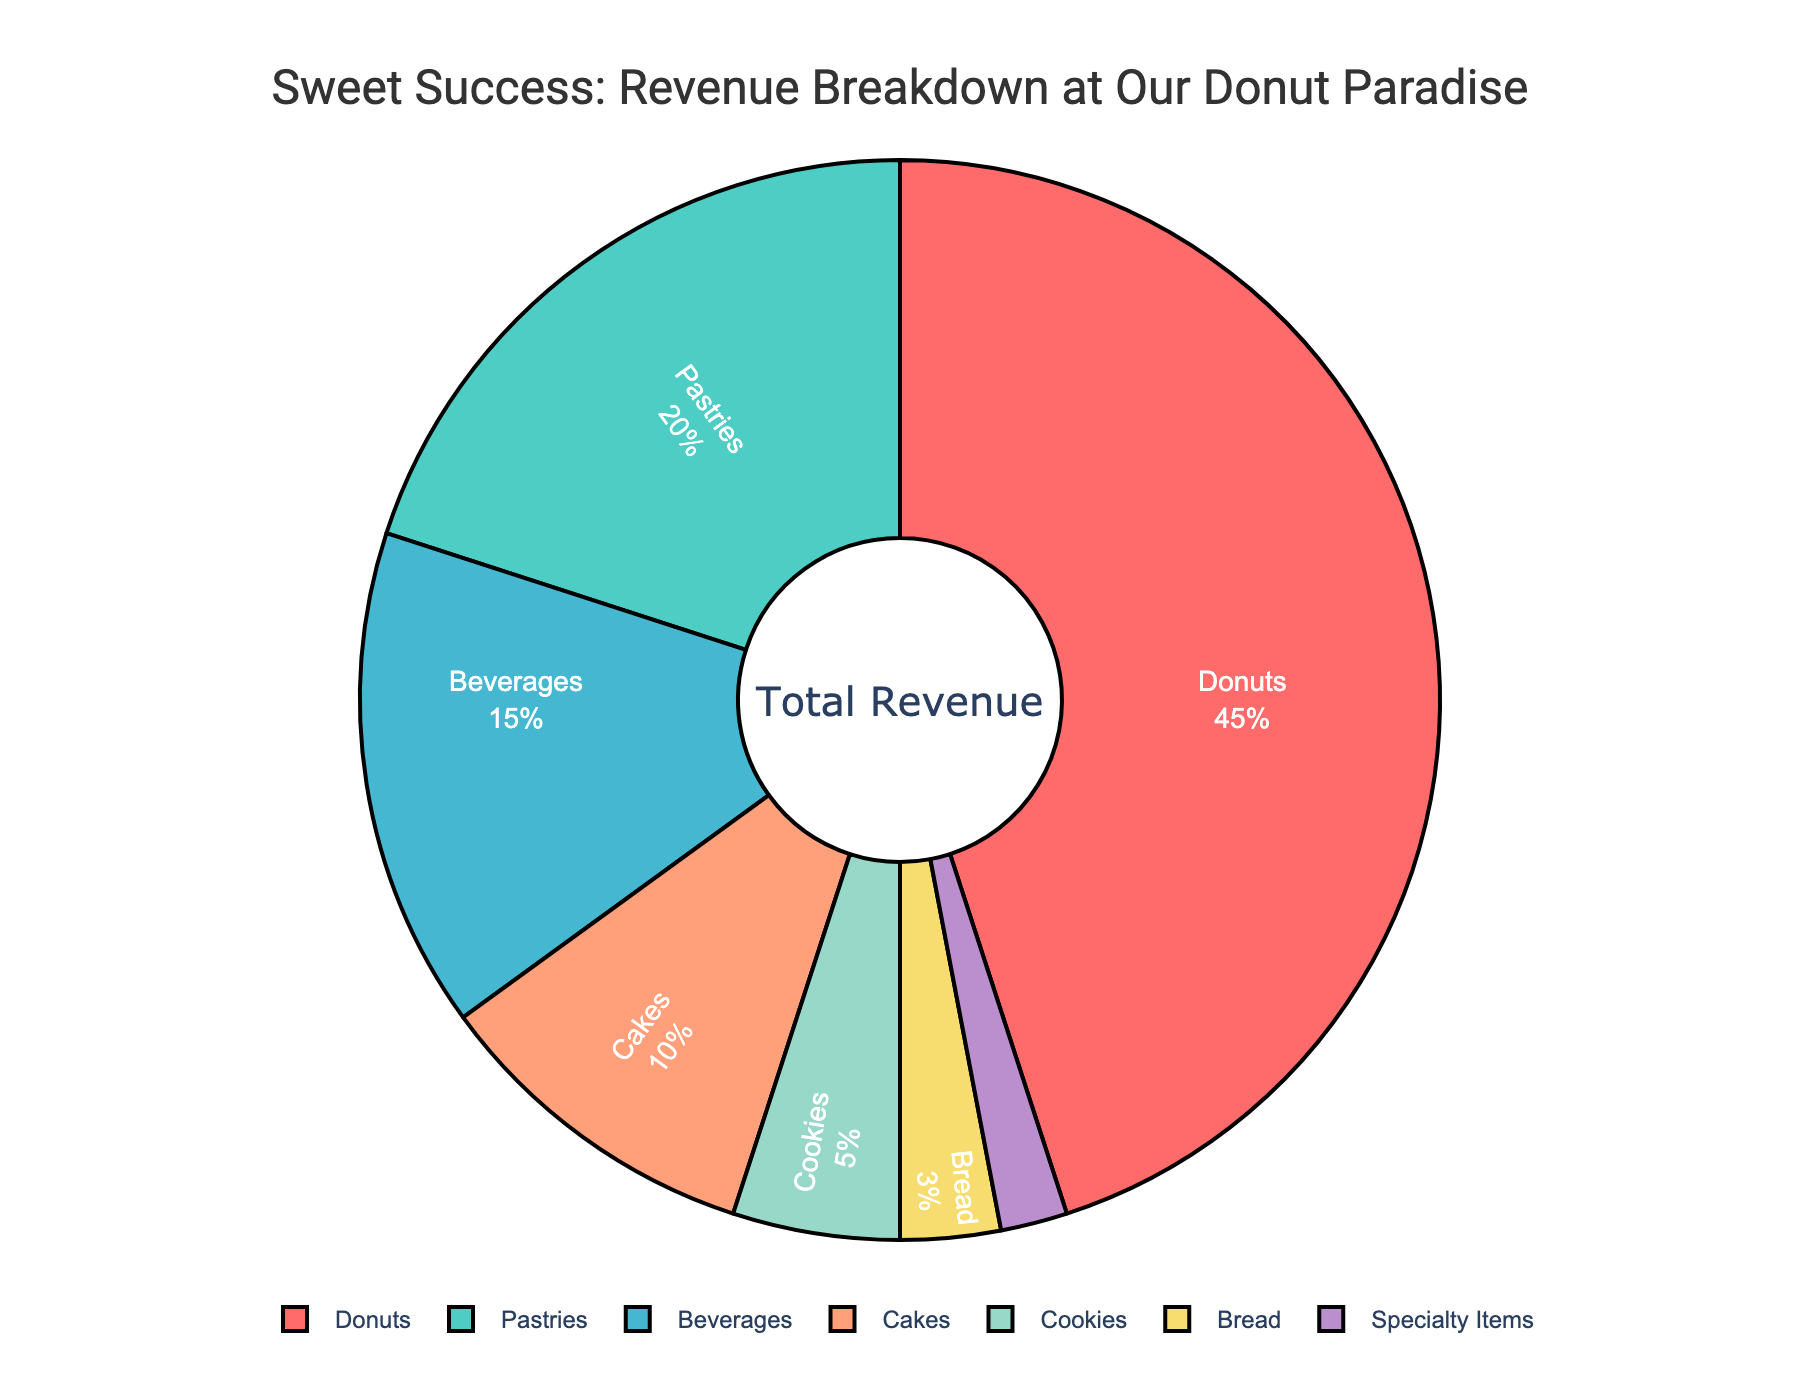Which product category generates the highest percentage of revenue? The largest segment of the pie chart belongs to the 'Donuts' category, indicating it contributes the highest percentage to the revenue.
Answer: Donuts How much more revenue percentage do donuts generate compared to beverages? The revenue percentage for donuts is 45%, and for beverages, it is 15%. The difference can be calculated as 45% - 15% = 30%.
Answer: 30% Which two product categories combined generate the same percentage of revenue as donuts? Pastries contribute 20% and cakes contribute 10%, combining these we get 20% + 10% = 30%. This is not equal to donuts' 45%. Combining pastries (20%) and beverages (15%) yields 20% + 15% = 35%, still not equal. The closest combination is pastries (20%), beverages (15%), and cookies (5%), 20% + 15% + 5% = 40%. Therefore, no combination of two categories matches the donut's revenue percentage.
Answer: None What percentage of revenue comes from products other than donuts and pastries? To find this, we subtract the revenue percentages of donuts and pastries from the total (100%): 100% - 45% - 20% = 35%.
Answer: 35% If cookies and specialty items doubled their revenue, what would be their combined revenue percentage? Currently, cookies contribute 5% and specialty items contribute 2%. Doubling each, we get 5% * 2 = 10% and 2% * 2 = 4%. Their combined doubled revenue will be 10% + 4% = 14%.
Answer: 14% How does the revenue percentage of cakes compare with that of pastries? The revenue percentage for cakes is 10%, while for pastries it’s 20%. Since 10% is less than 20%, cakes generate less revenue compared to pastries.
Answer: Cakes generate less revenue than pastries What fraction of the total revenue is generated by cakes, cookies, and bread combined? Cakes contribute 10%, cookies 5%, and bread 3%. Adding these together: 10% + 5% + 3% = 18%. Therefore, the fraction of total revenue is 18/100 or 9/50 in simplified form.
Answer: 9/50 Which product category has the smallest contribution to the revenue? The smallest segment of the pie chart corresponds to 'Specialty Items', indicating it contributes the least to the revenue, with 2%.
Answer: Specialty Items If pastries' revenue percentage increased by 10%, how would its revenue percentage compare to donuts then? Currently, pastries contribute 20%. An increase of 10% would make it 20% + 10% = 30%. Donuts contribute 45%, so even with a 10% increase, pastries' revenue percentage would still be less than that of donuts, 30% < 45%.
Answer: Less 